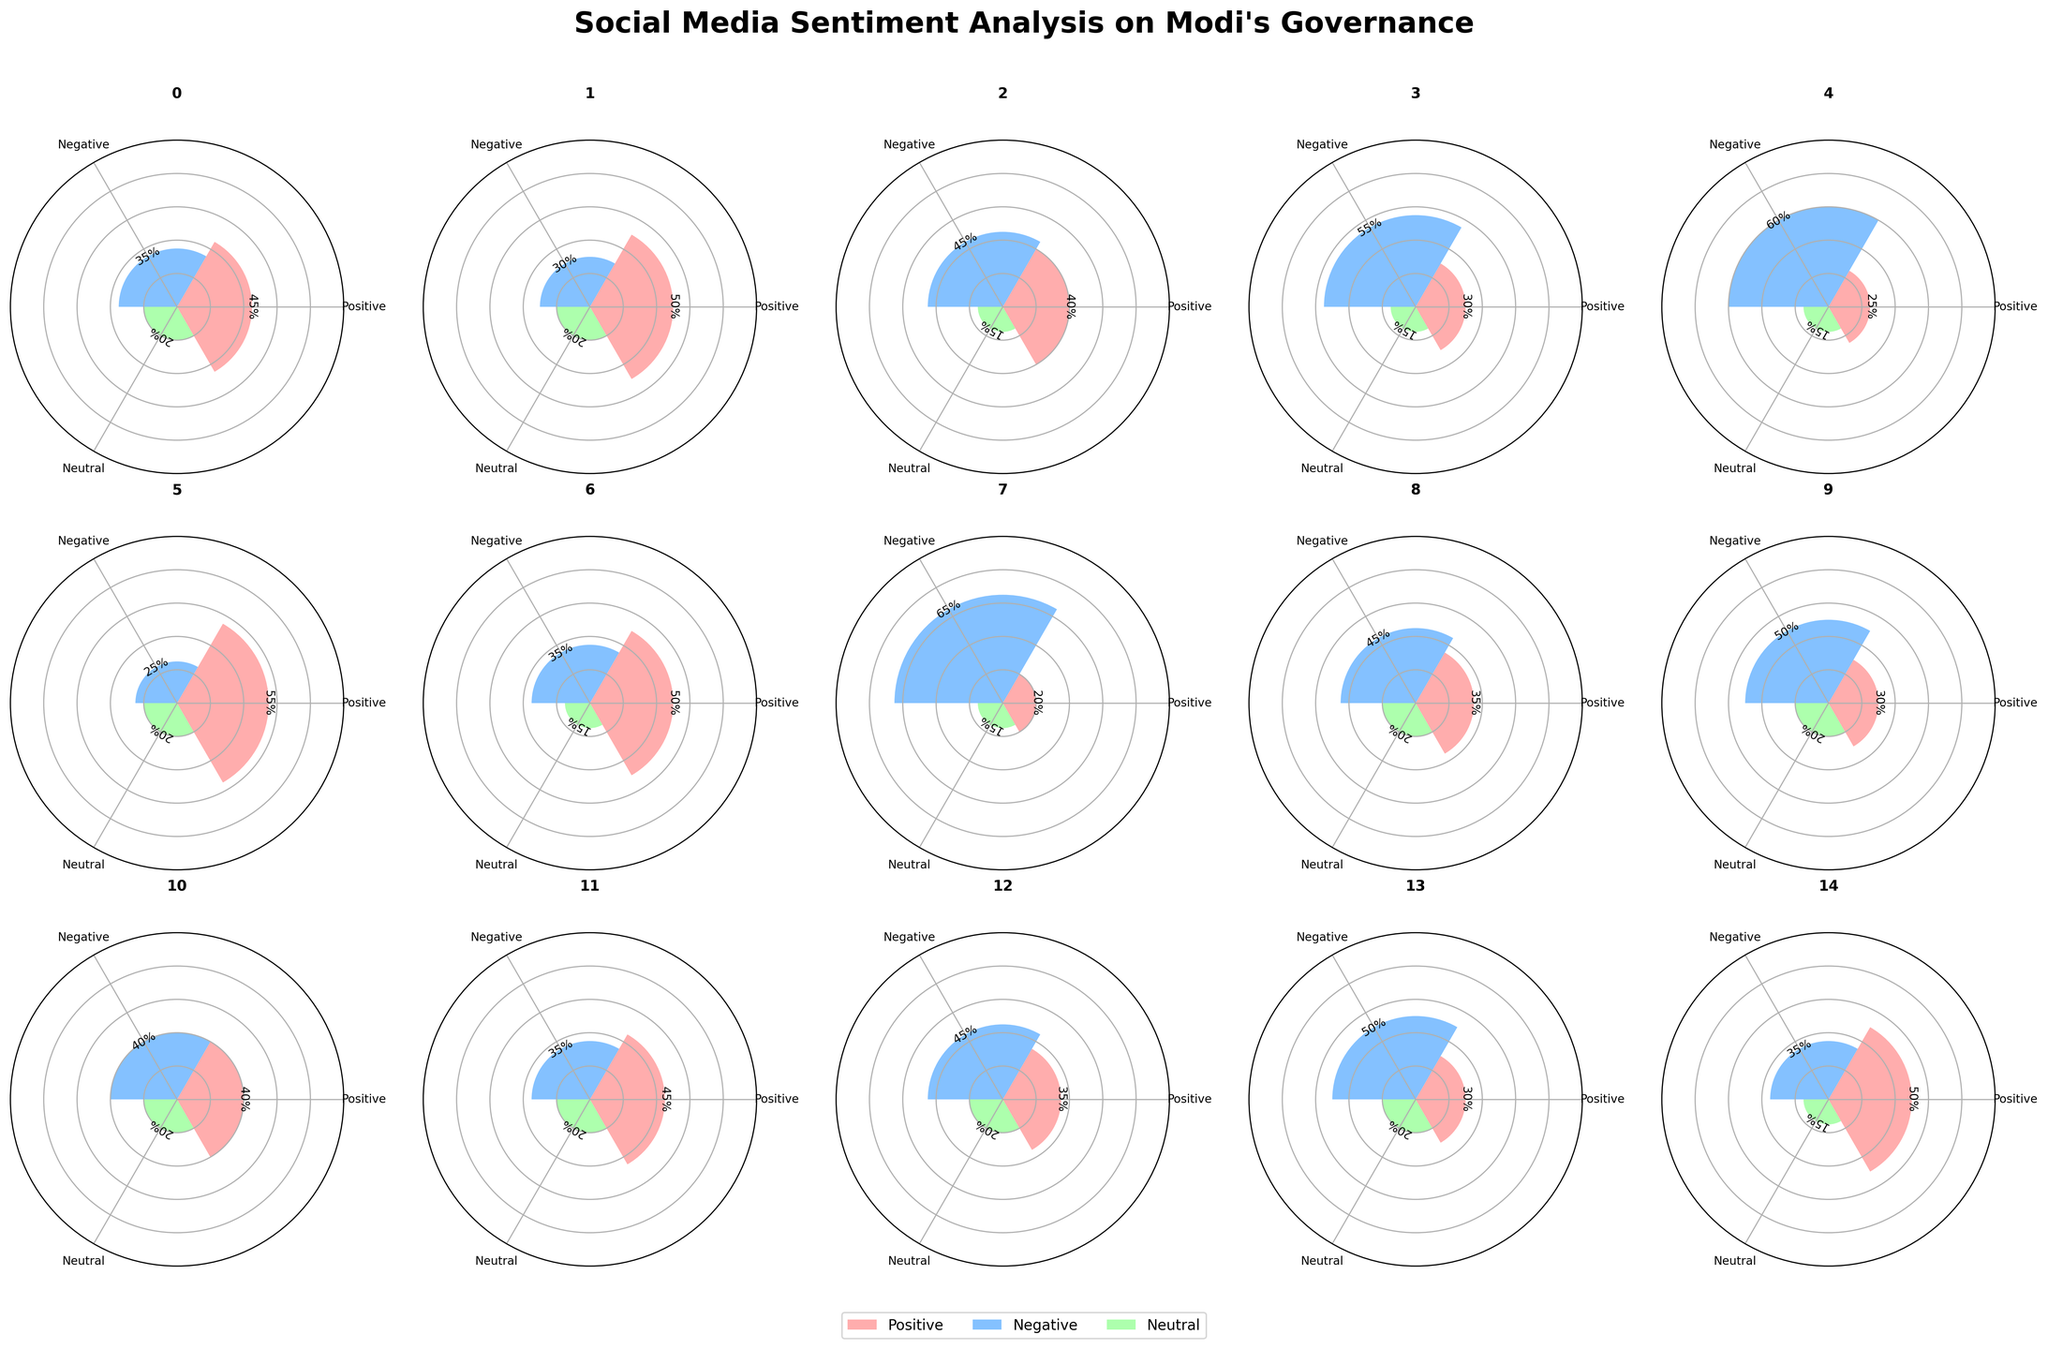What is the title of the figure? The title is usually located at the top of the figure, and it summarizes the overall content or the main focus. In this case, the title is “Social Media Sentiment Analysis on Modi’s Governance.”
Answer: "Social Media Sentiment Analysis on Modi's Governance" Which state has the highest positive sentiment percentage? To find the state with the highest positive sentiment percentage, we look for the state with the tallest bar segment in the positive color section (usually specified in the legend). Here, Gujarat has the highest positive sentiment percentage at 55%.
Answer: Gujarat Which state has the highest negative sentiment percentage? To find the state with the highest negative sentiment, we observe the tallest bar segment in the negative color section (as indicated in the legend). Kerala has the highest negative sentiment percentage at 65%.
Answer: Kerala Which state has an equal percentage of positive and negative sentiments? Look for bars where the heights of the segments representing positive and negative sentiments are equal. Bihar has an equal percentage of positive and negative sentiments, both at 40%.
Answer: Bihar How does the sentiment in Tamil Nadu compare with Maharashtra? Compare the heights of the bar segments for Tamil Nadu and Maharashtra. Tamil Nadu has lower positive sentiment (25% vs. 45%), higher negative sentiment (60% vs. 35%), and the same neutral sentiment (15% vs. 20%) compared to Maharashtra.
Answer: Tamil Nadu has lower positive sentiment, higher negative sentiment, and the same neutral sentiment compared to Maharashtra Which states have more negative sentiments than positive sentiments? Identify the states where the height of the segment representing negative sentiment exceeds the height of the segment representing the positive sentiment. The states are Delhi, West Bengal, Tamil Nadu, Kerala, Rajasthan, Punjab, and Telangana.
Answer: Delhi, West Bengal, Tamil Nadu, Kerala, Rajasthan, Punjab, Telangana How many states have a neutral sentiment percentage of 20%? Count the number of states where the neutral sentiment bar segment height indicates 20%. The states with a neutral sentiment of 20% are Maharashtra, Gujarat, Rajasthan, Bihar, Odisha, and Telangana.
Answer: 6 states Which state has the lowest positive sentiment? To find the state with the lowest positive sentiment, look for the shortest bar segment in the positive color. Kerala has the lowest positive sentiment at 20%.
Answer: Kerala What is the combined percentage of neutral sentiment across all states? Sum the neutral sentiment percentages for all states: 20+20+15+15+15+20+15+15+20+20+20+20+20+20+15 = 260%.
Answer: 260% What is the average positive sentiment percentage across the states? Calculate the average by summing the positive sentiment percentages and dividing by the number of states: (45+50+40+30+25+55+50+20+35+30+40+45+35+30+50)/15 = 39.33%.
Answer: 39.33% 